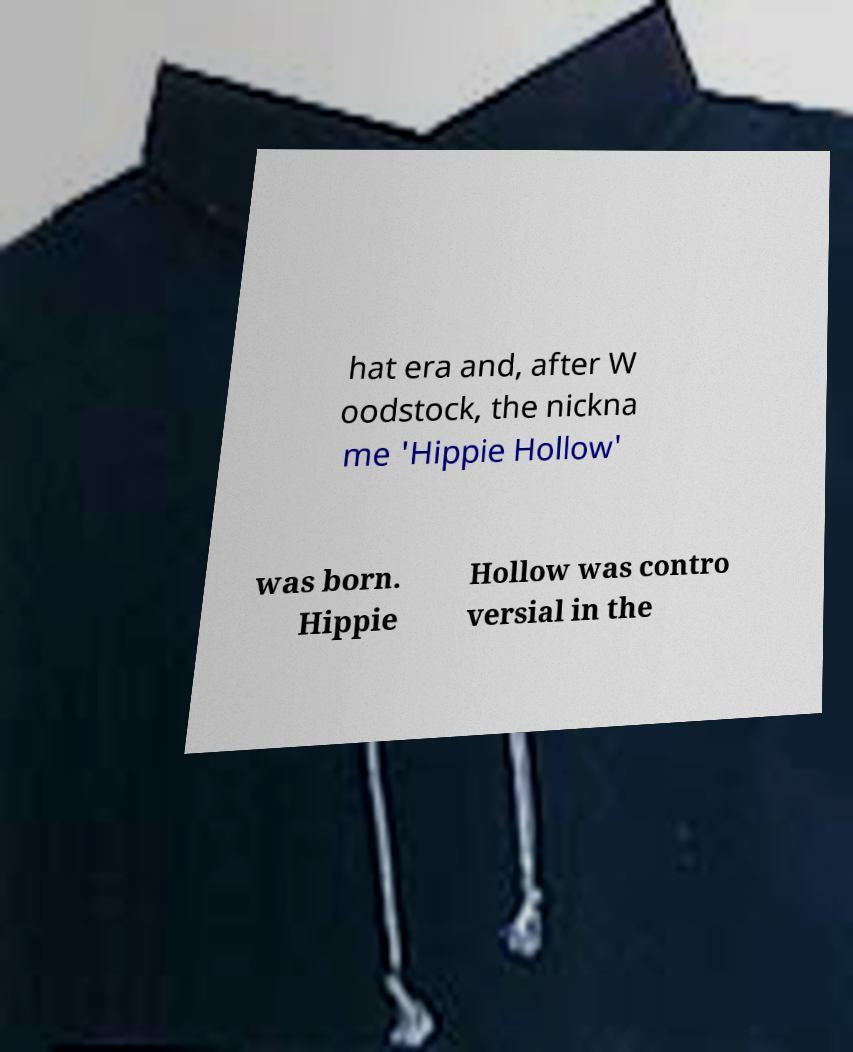Please read and relay the text visible in this image. What does it say? hat era and, after W oodstock, the nickna me 'Hippie Hollow' was born. Hippie Hollow was contro versial in the 